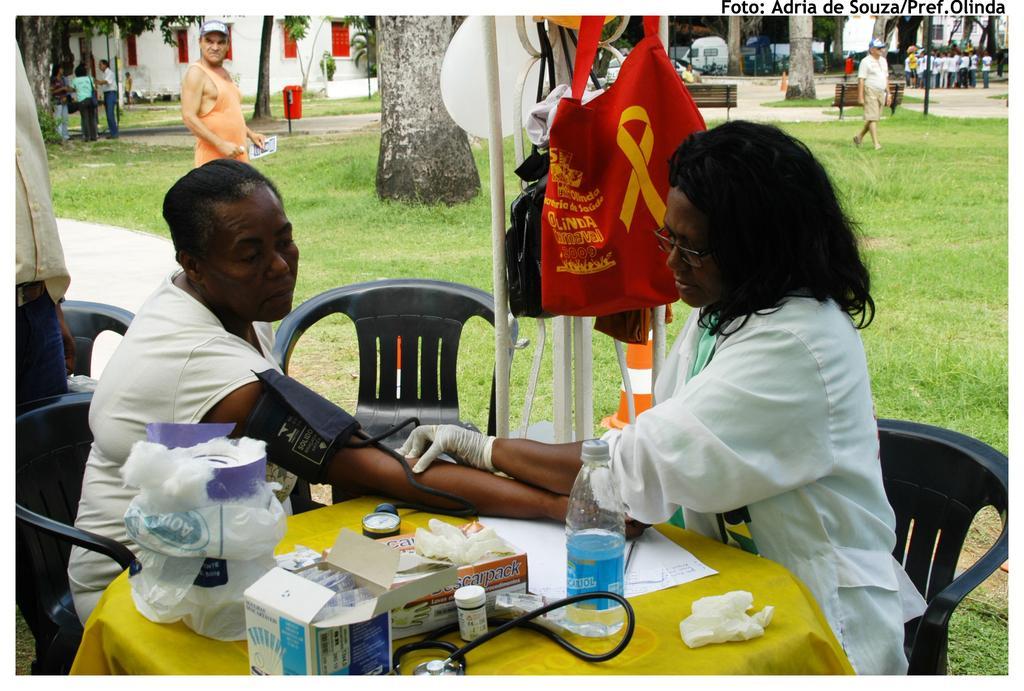Can you describe this image briefly? In this image, I can see two persons sitting on the chairs and there are groups of people standing. I can see a tissue paper box, water bottle, paper, stethoscope, cotton and few other things on a table, which is covered with a cloth. There are bags hanging to a pole. In the background, there are buildings, trees, a vehicle, a dustbin, benches and the grass. In the top right corner of the image, I can see a watermark. 